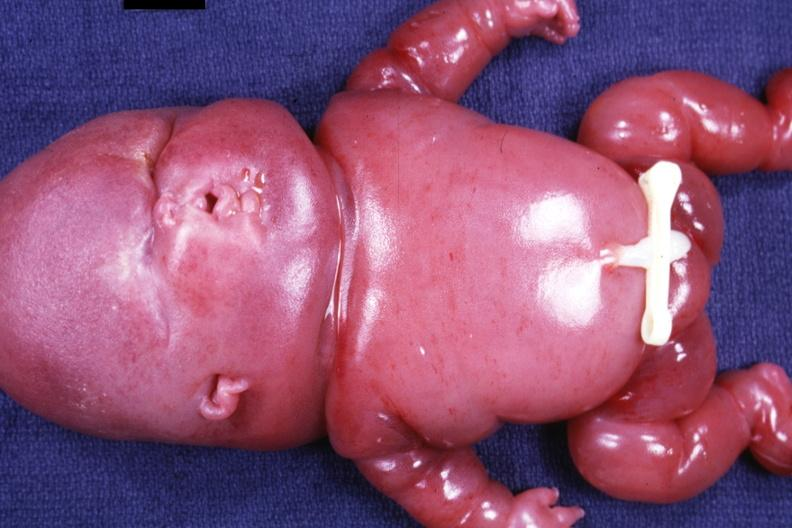what is present?
Answer the question using a single word or phrase. Lymphangiomatosis generalized 